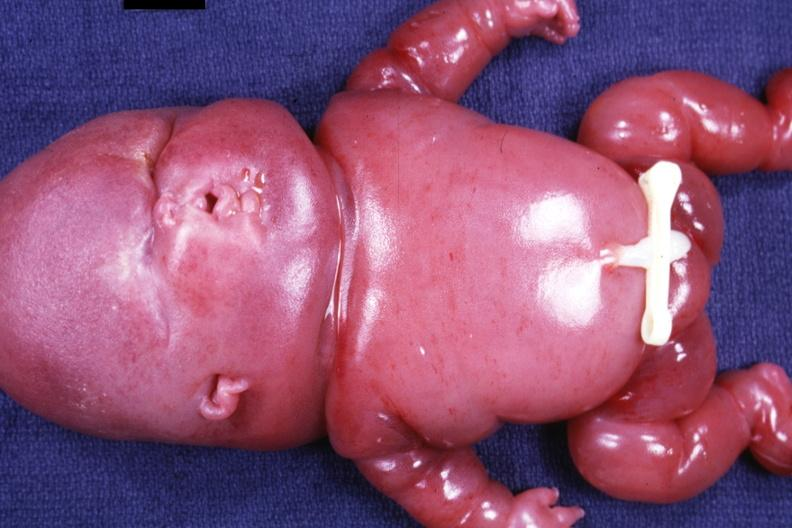what is present?
Answer the question using a single word or phrase. Lymphangiomatosis generalized 